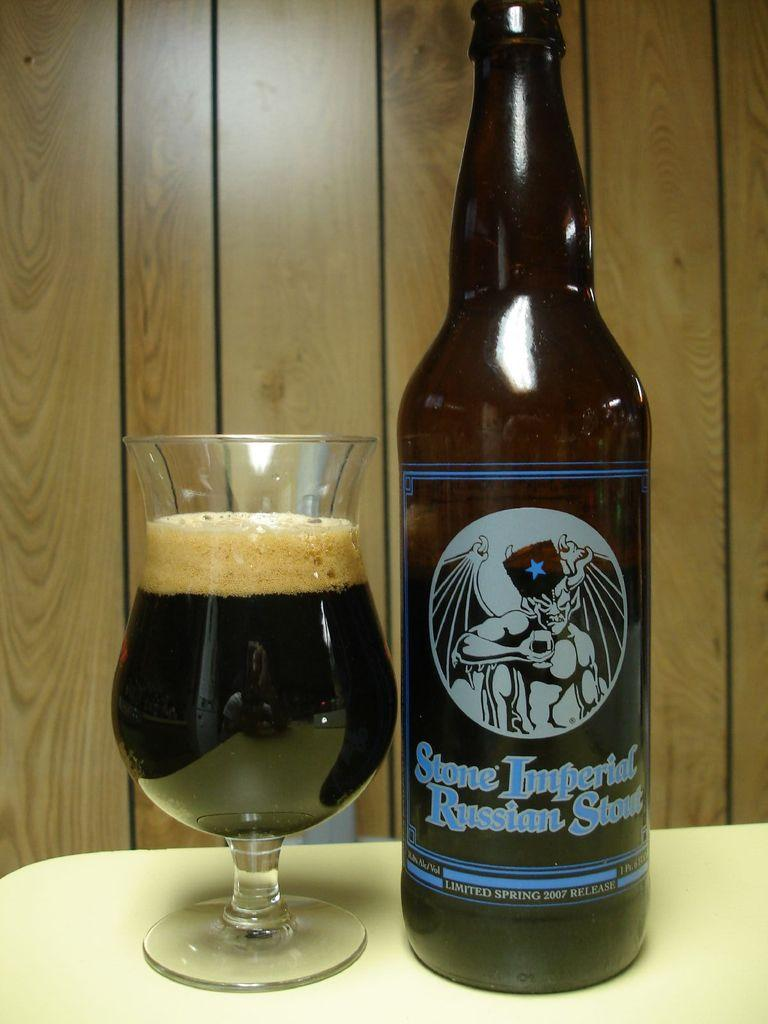<image>
Write a terse but informative summary of the picture. A glass almost full sitting next to a bottle that is Stone Imperial Russian Stout. 